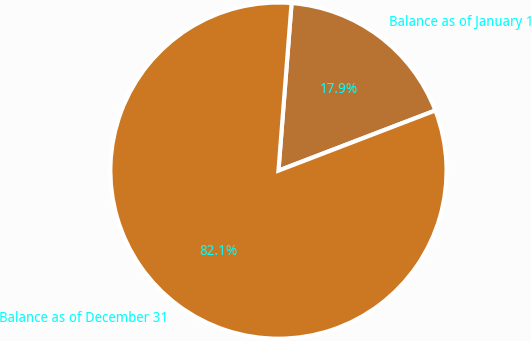<chart> <loc_0><loc_0><loc_500><loc_500><pie_chart><fcel>Balance as of January 1<fcel>Balance as of December 31<nl><fcel>17.93%<fcel>82.07%<nl></chart> 